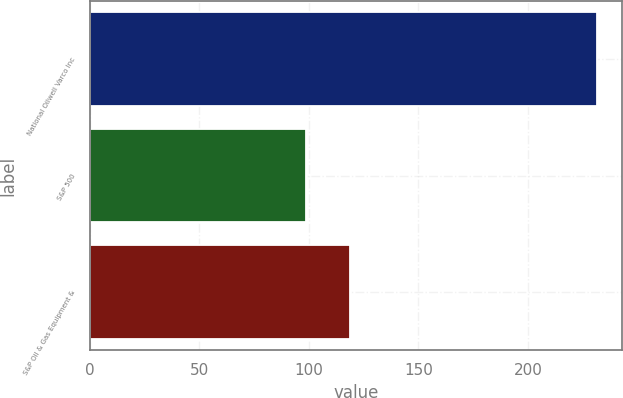<chart> <loc_0><loc_0><loc_500><loc_500><bar_chart><fcel>National Oilwell Varco Inc<fcel>S&P 500<fcel>S&P Oil & Gas Equipment &<nl><fcel>231.55<fcel>98.75<fcel>118.68<nl></chart> 